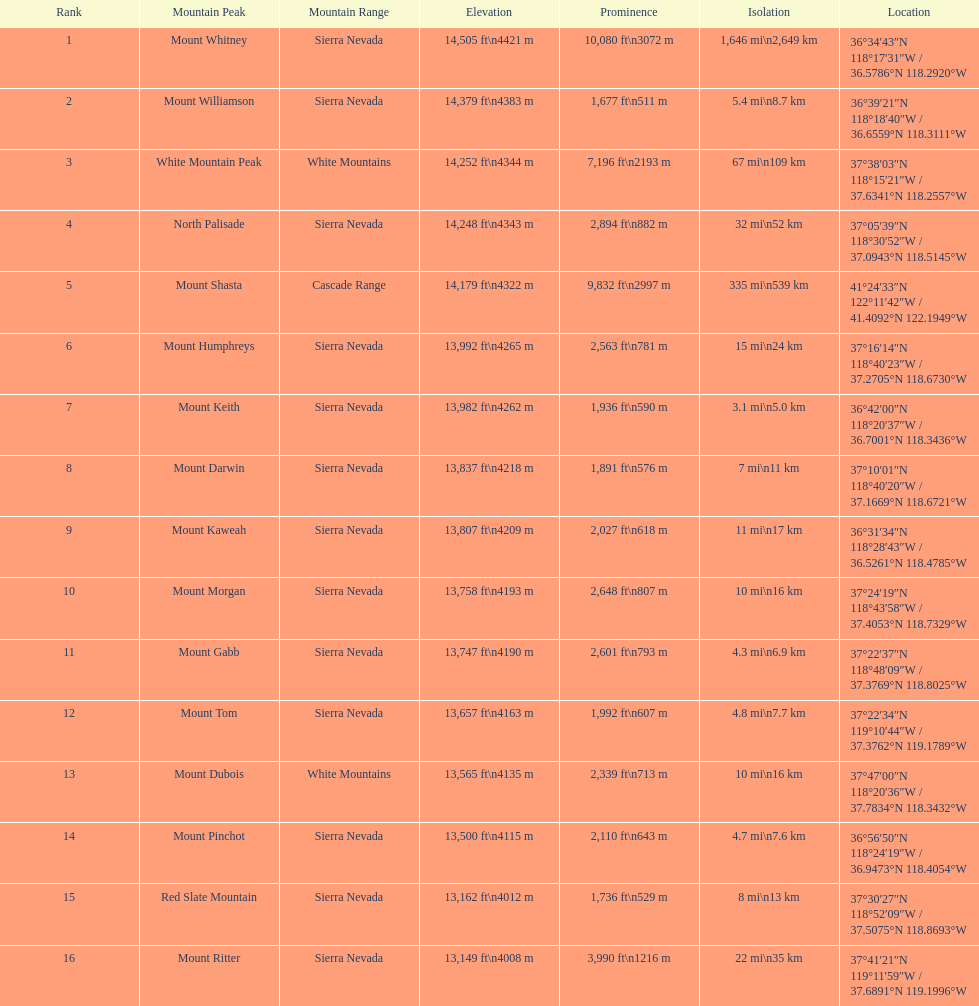In california, what is the height difference in feet between the tallest and the 9th tallest mountain peak? 698 ft. 